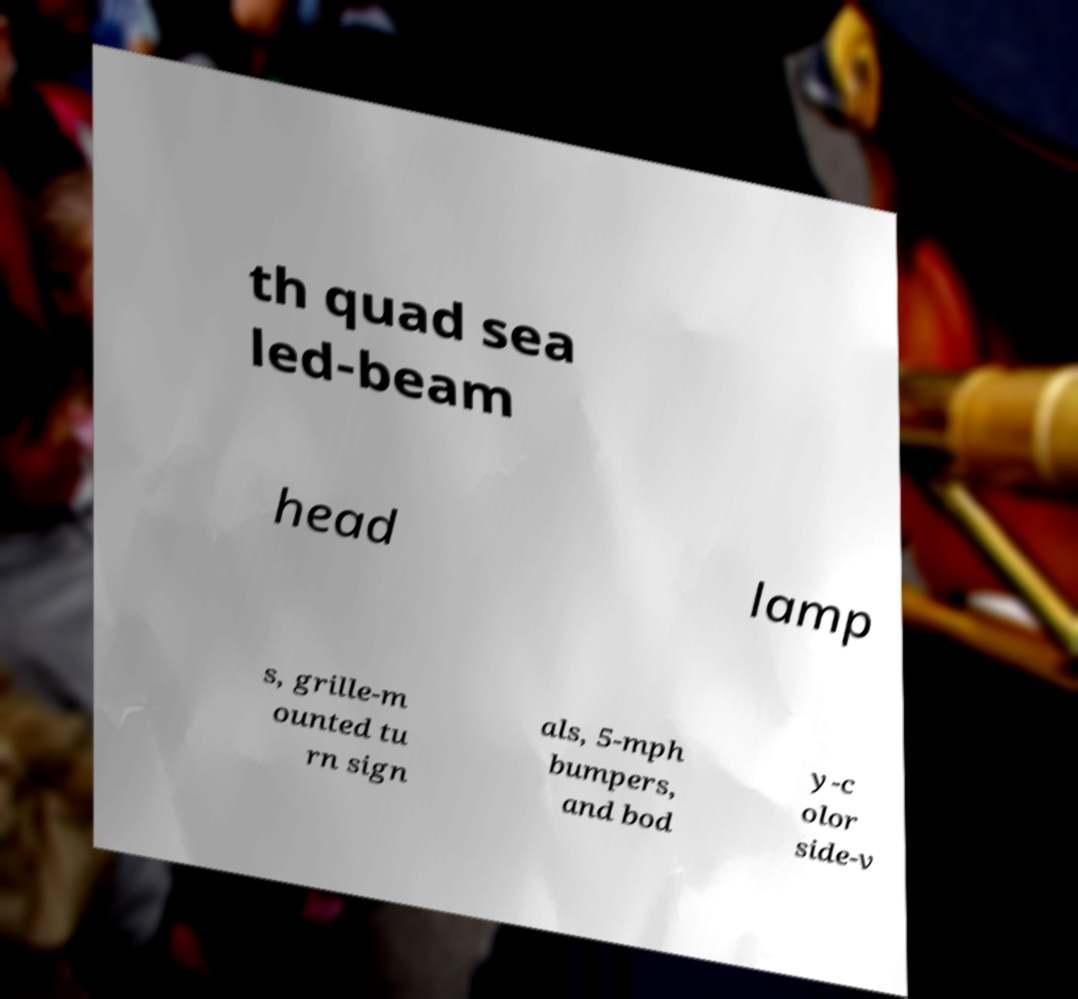Please identify and transcribe the text found in this image. th quad sea led-beam head lamp s, grille-m ounted tu rn sign als, 5-mph bumpers, and bod y-c olor side-v 